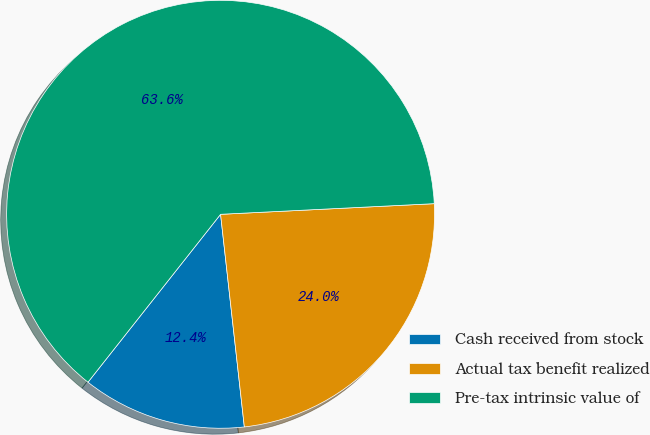Convert chart. <chart><loc_0><loc_0><loc_500><loc_500><pie_chart><fcel>Cash received from stock<fcel>Actual tax benefit realized<fcel>Pre-tax intrinsic value of<nl><fcel>12.41%<fcel>24.02%<fcel>63.57%<nl></chart> 